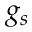Convert formula to latex. <formula><loc_0><loc_0><loc_500><loc_500>g _ { s }</formula> 